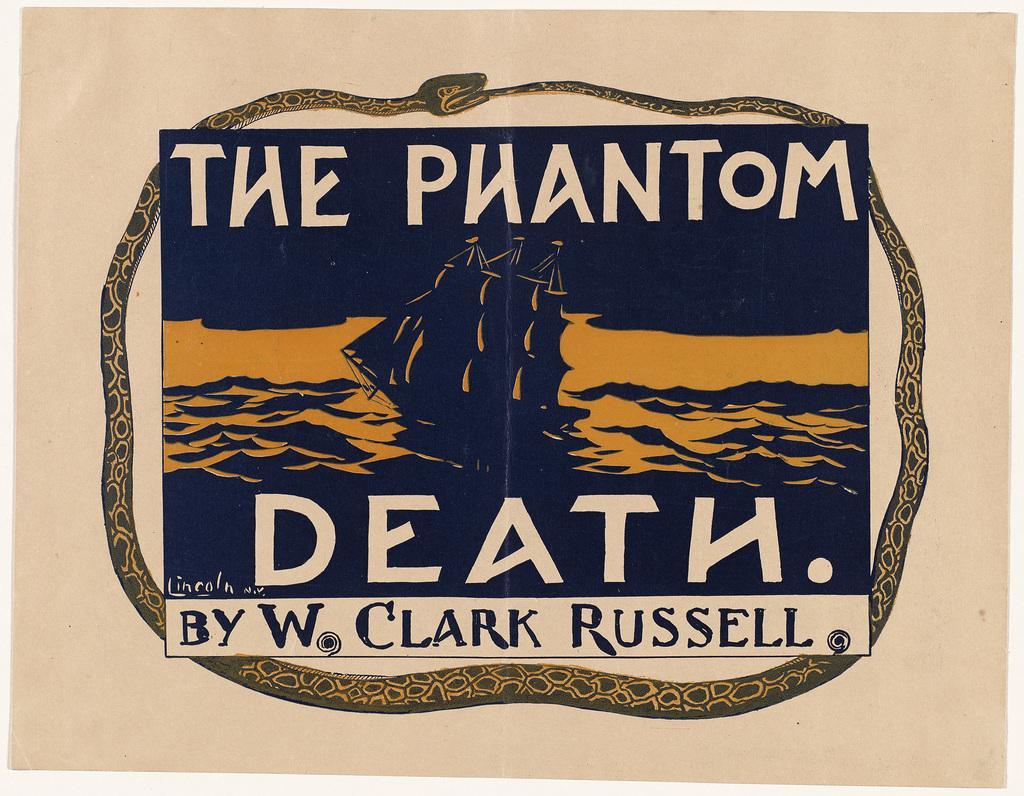How would you summarize this image in a sentence or two? In this image we can see a paper with picture and text on its top and bottom. 